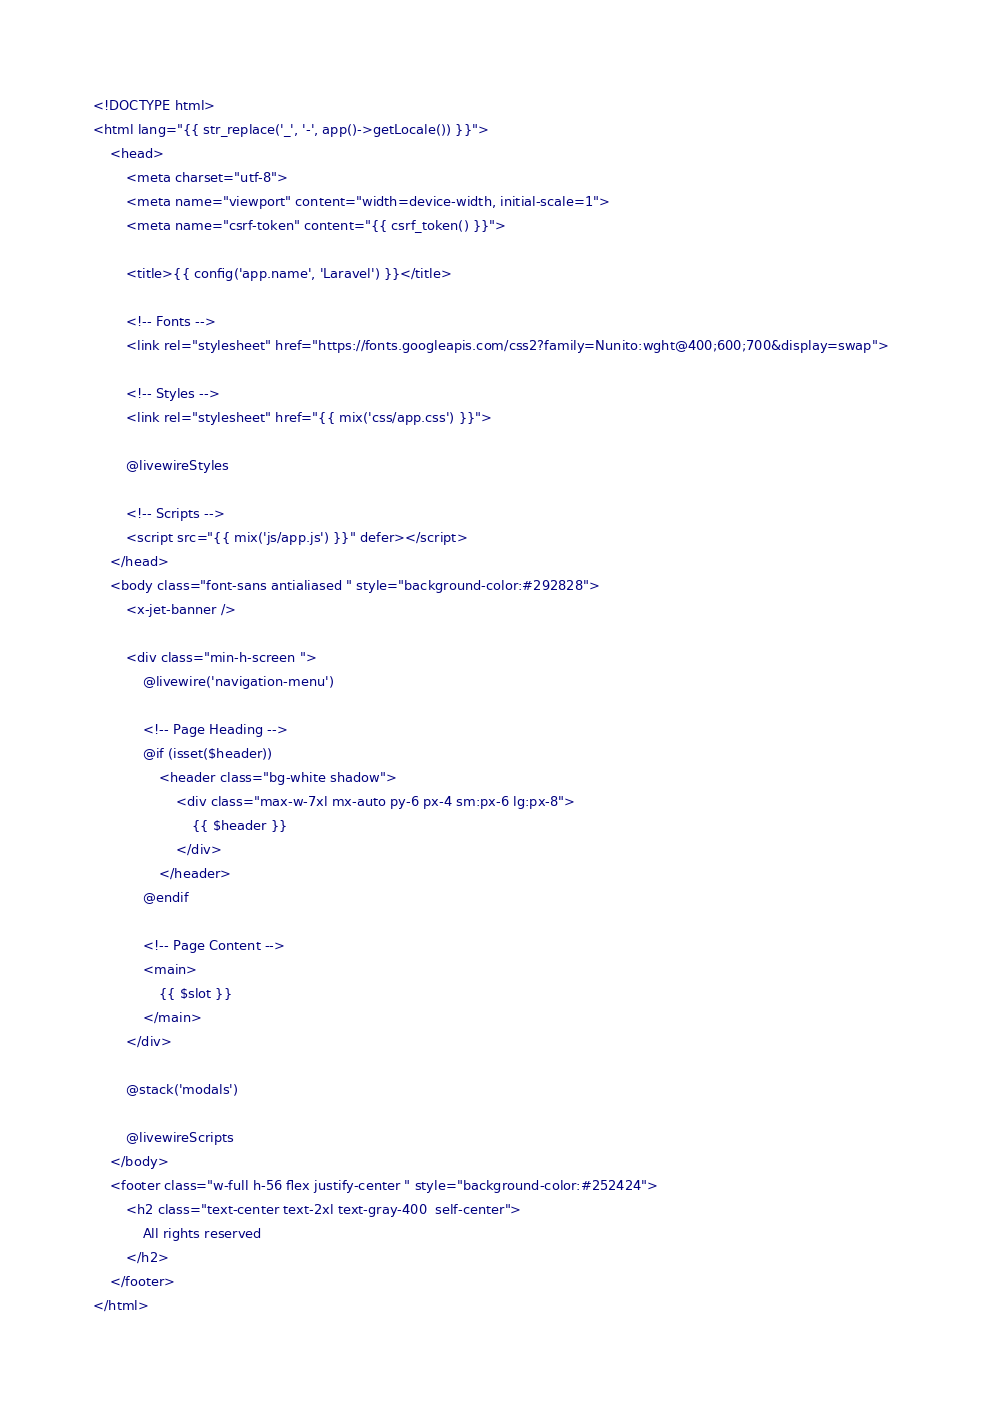Convert code to text. <code><loc_0><loc_0><loc_500><loc_500><_PHP_><!DOCTYPE html>
<html lang="{{ str_replace('_', '-', app()->getLocale()) }}">
    <head>
        <meta charset="utf-8">
        <meta name="viewport" content="width=device-width, initial-scale=1">
        <meta name="csrf-token" content="{{ csrf_token() }}">

        <title>{{ config('app.name', 'Laravel') }}</title>

        <!-- Fonts -->
        <link rel="stylesheet" href="https://fonts.googleapis.com/css2?family=Nunito:wght@400;600;700&display=swap">

        <!-- Styles -->
        <link rel="stylesheet" href="{{ mix('css/app.css') }}">

        @livewireStyles

        <!-- Scripts -->
        <script src="{{ mix('js/app.js') }}" defer></script>
    </head>
    <body class="font-sans antialiased " style="background-color:#292828">
        <x-jet-banner />

        <div class="min-h-screen ">
            @livewire('navigation-menu')

            <!-- Page Heading -->
            @if (isset($header))
                <header class="bg-white shadow">
                    <div class="max-w-7xl mx-auto py-6 px-4 sm:px-6 lg:px-8">
                        {{ $header }}
                    </div>
                </header>
            @endif

            <!-- Page Content -->
            <main>
                {{ $slot }}
            </main>
        </div>

        @stack('modals')

        @livewireScripts
    </body>
    <footer class="w-full h-56 flex justify-center " style="background-color:#252424">
        <h2 class="text-center text-2xl text-gray-400  self-center">
            All rights reserved
        </h2> 
    </footer>
</html>
</code> 